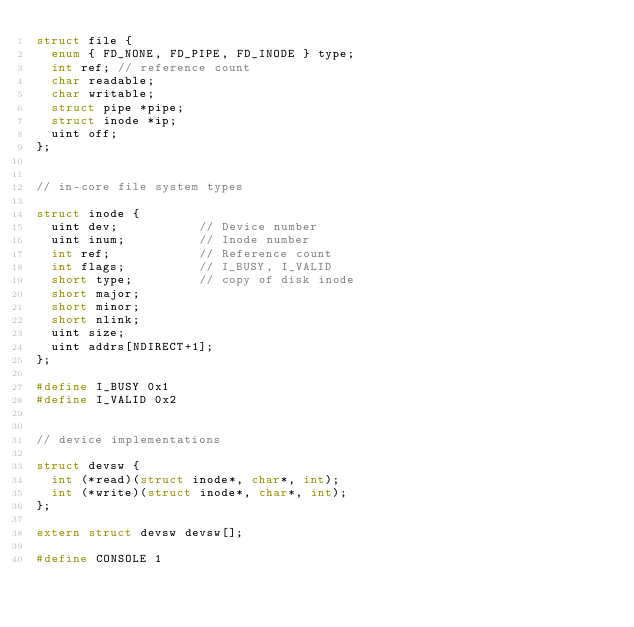Convert code to text. <code><loc_0><loc_0><loc_500><loc_500><_C_>struct file {
  enum { FD_NONE, FD_PIPE, FD_INODE } type;
  int ref; // reference count
  char readable;
  char writable;
  struct pipe *pipe;
  struct inode *ip;
  uint off;
};


// in-core file system types

struct inode {
  uint dev;           // Device number
  uint inum;          // Inode number
  int ref;            // Reference count
  int flags;          // I_BUSY, I_VALID 
  short type;         // copy of disk inode
  short major;
  short minor;
  short nlink;
  uint size;
  uint addrs[NDIRECT+1];
};

#define I_BUSY 0x1
#define I_VALID 0x2


// device implementations

struct devsw {
  int (*read)(struct inode*, char*, int);
  int (*write)(struct inode*, char*, int);
};

extern struct devsw devsw[];

#define CONSOLE 1
</code> 